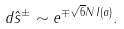<formula> <loc_0><loc_0><loc_500><loc_500>d \hat { s } ^ { \pm } \sim e ^ { \mp \sqrt { 6 } N \, I ( a ) } .</formula> 